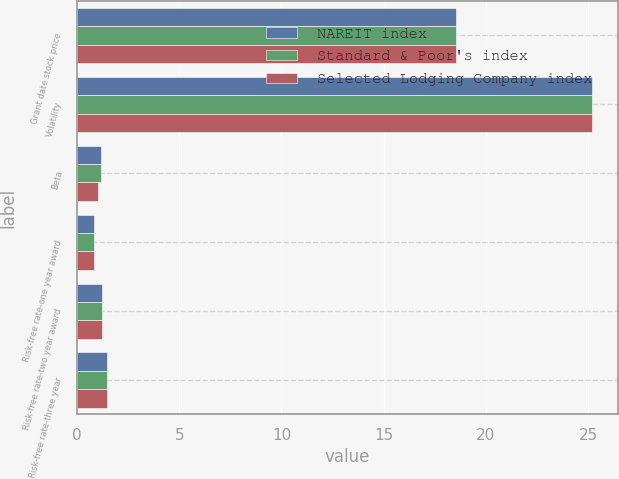Convert chart. <chart><loc_0><loc_0><loc_500><loc_500><stacked_bar_chart><ecel><fcel>Grant date stock price<fcel>Volatility<fcel>Beta<fcel>Risk-free rate-one year award<fcel>Risk-free rate-two year award<fcel>Risk-free rate-three year<nl><fcel>NAREIT index<fcel>18.56<fcel>25.2<fcel>1.18<fcel>0.82<fcel>1.2<fcel>1.48<nl><fcel>Standard & Poor's index<fcel>18.56<fcel>25.2<fcel>1.18<fcel>0.82<fcel>1.2<fcel>1.48<nl><fcel>Selected Lodging Company index<fcel>18.56<fcel>25.2<fcel>1.01<fcel>0.82<fcel>1.2<fcel>1.48<nl></chart> 